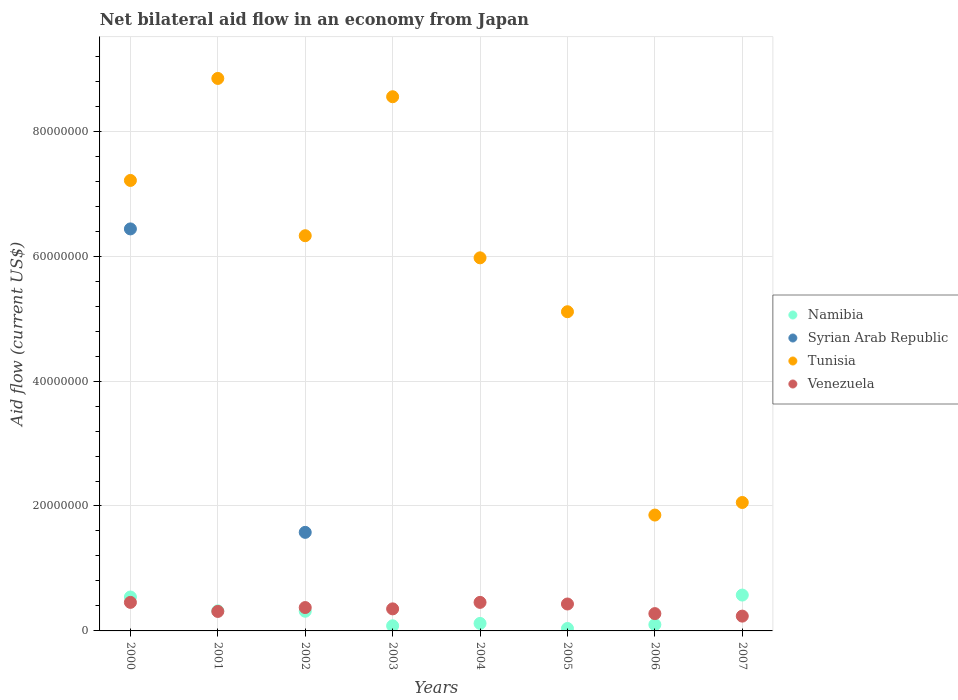What is the net bilateral aid flow in Tunisia in 2000?
Offer a terse response. 7.21e+07. Across all years, what is the maximum net bilateral aid flow in Namibia?
Ensure brevity in your answer.  5.74e+06. Across all years, what is the minimum net bilateral aid flow in Tunisia?
Provide a short and direct response. 1.86e+07. In which year was the net bilateral aid flow in Namibia maximum?
Provide a short and direct response. 2007. What is the total net bilateral aid flow in Syrian Arab Republic in the graph?
Ensure brevity in your answer.  8.01e+07. What is the difference between the net bilateral aid flow in Tunisia in 2005 and the net bilateral aid flow in Namibia in 2000?
Your answer should be very brief. 4.57e+07. What is the average net bilateral aid flow in Namibia per year?
Your answer should be very brief. 2.62e+06. In the year 2001, what is the difference between the net bilateral aid flow in Namibia and net bilateral aid flow in Tunisia?
Offer a very short reply. -8.52e+07. What is the ratio of the net bilateral aid flow in Tunisia in 2002 to that in 2003?
Your response must be concise. 0.74. What is the difference between the highest and the second highest net bilateral aid flow in Venezuela?
Keep it short and to the point. 0. What is the difference between the highest and the lowest net bilateral aid flow in Syrian Arab Republic?
Offer a very short reply. 6.44e+07. Is the sum of the net bilateral aid flow in Namibia in 2002 and 2004 greater than the maximum net bilateral aid flow in Syrian Arab Republic across all years?
Your answer should be very brief. No. Is it the case that in every year, the sum of the net bilateral aid flow in Namibia and net bilateral aid flow in Tunisia  is greater than the sum of net bilateral aid flow in Syrian Arab Republic and net bilateral aid flow in Venezuela?
Keep it short and to the point. No. Does the net bilateral aid flow in Tunisia monotonically increase over the years?
Provide a short and direct response. No. Is the net bilateral aid flow in Syrian Arab Republic strictly greater than the net bilateral aid flow in Tunisia over the years?
Your answer should be compact. No. How many years are there in the graph?
Offer a very short reply. 8. Where does the legend appear in the graph?
Give a very brief answer. Center right. What is the title of the graph?
Give a very brief answer. Net bilateral aid flow in an economy from Japan. What is the label or title of the X-axis?
Offer a terse response. Years. What is the label or title of the Y-axis?
Offer a very short reply. Aid flow (current US$). What is the Aid flow (current US$) of Namibia in 2000?
Your response must be concise. 5.43e+06. What is the Aid flow (current US$) in Syrian Arab Republic in 2000?
Your response must be concise. 6.44e+07. What is the Aid flow (current US$) in Tunisia in 2000?
Keep it short and to the point. 7.21e+07. What is the Aid flow (current US$) in Venezuela in 2000?
Give a very brief answer. 4.57e+06. What is the Aid flow (current US$) of Namibia in 2001?
Your answer should be very brief. 3.21e+06. What is the Aid flow (current US$) in Syrian Arab Republic in 2001?
Your answer should be compact. 0. What is the Aid flow (current US$) in Tunisia in 2001?
Your response must be concise. 8.84e+07. What is the Aid flow (current US$) in Venezuela in 2001?
Give a very brief answer. 3.12e+06. What is the Aid flow (current US$) in Namibia in 2002?
Offer a terse response. 3.15e+06. What is the Aid flow (current US$) of Syrian Arab Republic in 2002?
Provide a succinct answer. 1.58e+07. What is the Aid flow (current US$) in Tunisia in 2002?
Your response must be concise. 6.33e+07. What is the Aid flow (current US$) in Venezuela in 2002?
Keep it short and to the point. 3.74e+06. What is the Aid flow (current US$) of Namibia in 2003?
Keep it short and to the point. 8.20e+05. What is the Aid flow (current US$) of Tunisia in 2003?
Offer a terse response. 8.55e+07. What is the Aid flow (current US$) in Venezuela in 2003?
Your answer should be very brief. 3.53e+06. What is the Aid flow (current US$) in Namibia in 2004?
Your answer should be very brief. 1.20e+06. What is the Aid flow (current US$) in Syrian Arab Republic in 2004?
Your answer should be very brief. 0. What is the Aid flow (current US$) of Tunisia in 2004?
Provide a succinct answer. 5.97e+07. What is the Aid flow (current US$) in Venezuela in 2004?
Give a very brief answer. 4.57e+06. What is the Aid flow (current US$) in Syrian Arab Republic in 2005?
Keep it short and to the point. 0. What is the Aid flow (current US$) of Tunisia in 2005?
Your answer should be compact. 5.11e+07. What is the Aid flow (current US$) of Venezuela in 2005?
Make the answer very short. 4.31e+06. What is the Aid flow (current US$) in Namibia in 2006?
Offer a very short reply. 1.01e+06. What is the Aid flow (current US$) in Tunisia in 2006?
Keep it short and to the point. 1.86e+07. What is the Aid flow (current US$) of Venezuela in 2006?
Give a very brief answer. 2.77e+06. What is the Aid flow (current US$) of Namibia in 2007?
Provide a short and direct response. 5.74e+06. What is the Aid flow (current US$) of Syrian Arab Republic in 2007?
Your answer should be very brief. 0. What is the Aid flow (current US$) of Tunisia in 2007?
Your answer should be compact. 2.06e+07. What is the Aid flow (current US$) in Venezuela in 2007?
Make the answer very short. 2.37e+06. Across all years, what is the maximum Aid flow (current US$) of Namibia?
Provide a succinct answer. 5.74e+06. Across all years, what is the maximum Aid flow (current US$) of Syrian Arab Republic?
Give a very brief answer. 6.44e+07. Across all years, what is the maximum Aid flow (current US$) in Tunisia?
Your response must be concise. 8.84e+07. Across all years, what is the maximum Aid flow (current US$) of Venezuela?
Offer a terse response. 4.57e+06. Across all years, what is the minimum Aid flow (current US$) of Syrian Arab Republic?
Your response must be concise. 0. Across all years, what is the minimum Aid flow (current US$) in Tunisia?
Provide a succinct answer. 1.86e+07. Across all years, what is the minimum Aid flow (current US$) in Venezuela?
Your answer should be compact. 2.37e+06. What is the total Aid flow (current US$) of Namibia in the graph?
Provide a short and direct response. 2.10e+07. What is the total Aid flow (current US$) of Syrian Arab Republic in the graph?
Keep it short and to the point. 8.01e+07. What is the total Aid flow (current US$) of Tunisia in the graph?
Give a very brief answer. 4.59e+08. What is the total Aid flow (current US$) in Venezuela in the graph?
Offer a terse response. 2.90e+07. What is the difference between the Aid flow (current US$) of Namibia in 2000 and that in 2001?
Provide a succinct answer. 2.22e+06. What is the difference between the Aid flow (current US$) in Tunisia in 2000 and that in 2001?
Offer a terse response. -1.63e+07. What is the difference between the Aid flow (current US$) in Venezuela in 2000 and that in 2001?
Make the answer very short. 1.45e+06. What is the difference between the Aid flow (current US$) of Namibia in 2000 and that in 2002?
Provide a succinct answer. 2.28e+06. What is the difference between the Aid flow (current US$) in Syrian Arab Republic in 2000 and that in 2002?
Offer a terse response. 4.86e+07. What is the difference between the Aid flow (current US$) of Tunisia in 2000 and that in 2002?
Your response must be concise. 8.85e+06. What is the difference between the Aid flow (current US$) of Venezuela in 2000 and that in 2002?
Provide a succinct answer. 8.30e+05. What is the difference between the Aid flow (current US$) in Namibia in 2000 and that in 2003?
Offer a terse response. 4.61e+06. What is the difference between the Aid flow (current US$) in Tunisia in 2000 and that in 2003?
Offer a terse response. -1.34e+07. What is the difference between the Aid flow (current US$) in Venezuela in 2000 and that in 2003?
Keep it short and to the point. 1.04e+06. What is the difference between the Aid flow (current US$) of Namibia in 2000 and that in 2004?
Offer a very short reply. 4.23e+06. What is the difference between the Aid flow (current US$) of Tunisia in 2000 and that in 2004?
Your answer should be compact. 1.24e+07. What is the difference between the Aid flow (current US$) of Venezuela in 2000 and that in 2004?
Keep it short and to the point. 0. What is the difference between the Aid flow (current US$) in Namibia in 2000 and that in 2005?
Make the answer very short. 5.04e+06. What is the difference between the Aid flow (current US$) of Tunisia in 2000 and that in 2005?
Your response must be concise. 2.10e+07. What is the difference between the Aid flow (current US$) in Venezuela in 2000 and that in 2005?
Your response must be concise. 2.60e+05. What is the difference between the Aid flow (current US$) of Namibia in 2000 and that in 2006?
Your answer should be compact. 4.42e+06. What is the difference between the Aid flow (current US$) in Tunisia in 2000 and that in 2006?
Keep it short and to the point. 5.36e+07. What is the difference between the Aid flow (current US$) in Venezuela in 2000 and that in 2006?
Offer a very short reply. 1.80e+06. What is the difference between the Aid flow (current US$) of Namibia in 2000 and that in 2007?
Offer a very short reply. -3.10e+05. What is the difference between the Aid flow (current US$) in Tunisia in 2000 and that in 2007?
Your answer should be very brief. 5.16e+07. What is the difference between the Aid flow (current US$) in Venezuela in 2000 and that in 2007?
Offer a very short reply. 2.20e+06. What is the difference between the Aid flow (current US$) in Tunisia in 2001 and that in 2002?
Your response must be concise. 2.52e+07. What is the difference between the Aid flow (current US$) in Venezuela in 2001 and that in 2002?
Give a very brief answer. -6.20e+05. What is the difference between the Aid flow (current US$) in Namibia in 2001 and that in 2003?
Ensure brevity in your answer.  2.39e+06. What is the difference between the Aid flow (current US$) in Tunisia in 2001 and that in 2003?
Provide a succinct answer. 2.93e+06. What is the difference between the Aid flow (current US$) in Venezuela in 2001 and that in 2003?
Provide a succinct answer. -4.10e+05. What is the difference between the Aid flow (current US$) in Namibia in 2001 and that in 2004?
Your answer should be compact. 2.01e+06. What is the difference between the Aid flow (current US$) in Tunisia in 2001 and that in 2004?
Keep it short and to the point. 2.87e+07. What is the difference between the Aid flow (current US$) of Venezuela in 2001 and that in 2004?
Ensure brevity in your answer.  -1.45e+06. What is the difference between the Aid flow (current US$) of Namibia in 2001 and that in 2005?
Give a very brief answer. 2.82e+06. What is the difference between the Aid flow (current US$) of Tunisia in 2001 and that in 2005?
Give a very brief answer. 3.74e+07. What is the difference between the Aid flow (current US$) of Venezuela in 2001 and that in 2005?
Provide a short and direct response. -1.19e+06. What is the difference between the Aid flow (current US$) in Namibia in 2001 and that in 2006?
Give a very brief answer. 2.20e+06. What is the difference between the Aid flow (current US$) in Tunisia in 2001 and that in 2006?
Offer a very short reply. 6.99e+07. What is the difference between the Aid flow (current US$) of Venezuela in 2001 and that in 2006?
Your answer should be compact. 3.50e+05. What is the difference between the Aid flow (current US$) of Namibia in 2001 and that in 2007?
Offer a very short reply. -2.53e+06. What is the difference between the Aid flow (current US$) of Tunisia in 2001 and that in 2007?
Your response must be concise. 6.79e+07. What is the difference between the Aid flow (current US$) in Venezuela in 2001 and that in 2007?
Give a very brief answer. 7.50e+05. What is the difference between the Aid flow (current US$) in Namibia in 2002 and that in 2003?
Offer a very short reply. 2.33e+06. What is the difference between the Aid flow (current US$) of Tunisia in 2002 and that in 2003?
Give a very brief answer. -2.22e+07. What is the difference between the Aid flow (current US$) in Namibia in 2002 and that in 2004?
Make the answer very short. 1.95e+06. What is the difference between the Aid flow (current US$) in Tunisia in 2002 and that in 2004?
Ensure brevity in your answer.  3.54e+06. What is the difference between the Aid flow (current US$) of Venezuela in 2002 and that in 2004?
Offer a terse response. -8.30e+05. What is the difference between the Aid flow (current US$) in Namibia in 2002 and that in 2005?
Ensure brevity in your answer.  2.76e+06. What is the difference between the Aid flow (current US$) in Tunisia in 2002 and that in 2005?
Your answer should be compact. 1.22e+07. What is the difference between the Aid flow (current US$) in Venezuela in 2002 and that in 2005?
Give a very brief answer. -5.70e+05. What is the difference between the Aid flow (current US$) of Namibia in 2002 and that in 2006?
Your answer should be very brief. 2.14e+06. What is the difference between the Aid flow (current US$) in Tunisia in 2002 and that in 2006?
Ensure brevity in your answer.  4.47e+07. What is the difference between the Aid flow (current US$) in Venezuela in 2002 and that in 2006?
Keep it short and to the point. 9.70e+05. What is the difference between the Aid flow (current US$) in Namibia in 2002 and that in 2007?
Give a very brief answer. -2.59e+06. What is the difference between the Aid flow (current US$) of Tunisia in 2002 and that in 2007?
Your answer should be very brief. 4.27e+07. What is the difference between the Aid flow (current US$) of Venezuela in 2002 and that in 2007?
Provide a succinct answer. 1.37e+06. What is the difference between the Aid flow (current US$) of Namibia in 2003 and that in 2004?
Offer a very short reply. -3.80e+05. What is the difference between the Aid flow (current US$) of Tunisia in 2003 and that in 2004?
Provide a succinct answer. 2.58e+07. What is the difference between the Aid flow (current US$) of Venezuela in 2003 and that in 2004?
Offer a terse response. -1.04e+06. What is the difference between the Aid flow (current US$) of Namibia in 2003 and that in 2005?
Your answer should be very brief. 4.30e+05. What is the difference between the Aid flow (current US$) in Tunisia in 2003 and that in 2005?
Keep it short and to the point. 3.44e+07. What is the difference between the Aid flow (current US$) in Venezuela in 2003 and that in 2005?
Give a very brief answer. -7.80e+05. What is the difference between the Aid flow (current US$) of Tunisia in 2003 and that in 2006?
Your answer should be very brief. 6.70e+07. What is the difference between the Aid flow (current US$) of Venezuela in 2003 and that in 2006?
Offer a terse response. 7.60e+05. What is the difference between the Aid flow (current US$) in Namibia in 2003 and that in 2007?
Provide a succinct answer. -4.92e+06. What is the difference between the Aid flow (current US$) of Tunisia in 2003 and that in 2007?
Provide a short and direct response. 6.50e+07. What is the difference between the Aid flow (current US$) of Venezuela in 2003 and that in 2007?
Keep it short and to the point. 1.16e+06. What is the difference between the Aid flow (current US$) of Namibia in 2004 and that in 2005?
Offer a very short reply. 8.10e+05. What is the difference between the Aid flow (current US$) of Tunisia in 2004 and that in 2005?
Your response must be concise. 8.63e+06. What is the difference between the Aid flow (current US$) in Namibia in 2004 and that in 2006?
Give a very brief answer. 1.90e+05. What is the difference between the Aid flow (current US$) of Tunisia in 2004 and that in 2006?
Your answer should be compact. 4.12e+07. What is the difference between the Aid flow (current US$) in Venezuela in 2004 and that in 2006?
Give a very brief answer. 1.80e+06. What is the difference between the Aid flow (current US$) of Namibia in 2004 and that in 2007?
Offer a terse response. -4.54e+06. What is the difference between the Aid flow (current US$) of Tunisia in 2004 and that in 2007?
Offer a very short reply. 3.92e+07. What is the difference between the Aid flow (current US$) of Venezuela in 2004 and that in 2007?
Give a very brief answer. 2.20e+06. What is the difference between the Aid flow (current US$) in Namibia in 2005 and that in 2006?
Offer a very short reply. -6.20e+05. What is the difference between the Aid flow (current US$) of Tunisia in 2005 and that in 2006?
Offer a terse response. 3.26e+07. What is the difference between the Aid flow (current US$) in Venezuela in 2005 and that in 2006?
Offer a very short reply. 1.54e+06. What is the difference between the Aid flow (current US$) in Namibia in 2005 and that in 2007?
Offer a terse response. -5.35e+06. What is the difference between the Aid flow (current US$) in Tunisia in 2005 and that in 2007?
Make the answer very short. 3.05e+07. What is the difference between the Aid flow (current US$) in Venezuela in 2005 and that in 2007?
Your answer should be very brief. 1.94e+06. What is the difference between the Aid flow (current US$) in Namibia in 2006 and that in 2007?
Provide a succinct answer. -4.73e+06. What is the difference between the Aid flow (current US$) of Tunisia in 2006 and that in 2007?
Offer a very short reply. -2.01e+06. What is the difference between the Aid flow (current US$) of Namibia in 2000 and the Aid flow (current US$) of Tunisia in 2001?
Provide a succinct answer. -8.30e+07. What is the difference between the Aid flow (current US$) in Namibia in 2000 and the Aid flow (current US$) in Venezuela in 2001?
Your response must be concise. 2.31e+06. What is the difference between the Aid flow (current US$) of Syrian Arab Republic in 2000 and the Aid flow (current US$) of Tunisia in 2001?
Offer a very short reply. -2.41e+07. What is the difference between the Aid flow (current US$) of Syrian Arab Republic in 2000 and the Aid flow (current US$) of Venezuela in 2001?
Provide a short and direct response. 6.12e+07. What is the difference between the Aid flow (current US$) of Tunisia in 2000 and the Aid flow (current US$) of Venezuela in 2001?
Provide a short and direct response. 6.90e+07. What is the difference between the Aid flow (current US$) of Namibia in 2000 and the Aid flow (current US$) of Syrian Arab Republic in 2002?
Your answer should be compact. -1.04e+07. What is the difference between the Aid flow (current US$) of Namibia in 2000 and the Aid flow (current US$) of Tunisia in 2002?
Your answer should be compact. -5.78e+07. What is the difference between the Aid flow (current US$) in Namibia in 2000 and the Aid flow (current US$) in Venezuela in 2002?
Keep it short and to the point. 1.69e+06. What is the difference between the Aid flow (current US$) of Syrian Arab Republic in 2000 and the Aid flow (current US$) of Tunisia in 2002?
Ensure brevity in your answer.  1.09e+06. What is the difference between the Aid flow (current US$) of Syrian Arab Republic in 2000 and the Aid flow (current US$) of Venezuela in 2002?
Your answer should be compact. 6.06e+07. What is the difference between the Aid flow (current US$) of Tunisia in 2000 and the Aid flow (current US$) of Venezuela in 2002?
Your answer should be very brief. 6.84e+07. What is the difference between the Aid flow (current US$) in Namibia in 2000 and the Aid flow (current US$) in Tunisia in 2003?
Offer a terse response. -8.01e+07. What is the difference between the Aid flow (current US$) of Namibia in 2000 and the Aid flow (current US$) of Venezuela in 2003?
Provide a succinct answer. 1.90e+06. What is the difference between the Aid flow (current US$) of Syrian Arab Republic in 2000 and the Aid flow (current US$) of Tunisia in 2003?
Offer a very short reply. -2.12e+07. What is the difference between the Aid flow (current US$) of Syrian Arab Republic in 2000 and the Aid flow (current US$) of Venezuela in 2003?
Make the answer very short. 6.08e+07. What is the difference between the Aid flow (current US$) in Tunisia in 2000 and the Aid flow (current US$) in Venezuela in 2003?
Your answer should be very brief. 6.86e+07. What is the difference between the Aid flow (current US$) of Namibia in 2000 and the Aid flow (current US$) of Tunisia in 2004?
Offer a terse response. -5.43e+07. What is the difference between the Aid flow (current US$) of Namibia in 2000 and the Aid flow (current US$) of Venezuela in 2004?
Your answer should be very brief. 8.60e+05. What is the difference between the Aid flow (current US$) in Syrian Arab Republic in 2000 and the Aid flow (current US$) in Tunisia in 2004?
Keep it short and to the point. 4.63e+06. What is the difference between the Aid flow (current US$) in Syrian Arab Republic in 2000 and the Aid flow (current US$) in Venezuela in 2004?
Your answer should be very brief. 5.98e+07. What is the difference between the Aid flow (current US$) of Tunisia in 2000 and the Aid flow (current US$) of Venezuela in 2004?
Your response must be concise. 6.76e+07. What is the difference between the Aid flow (current US$) of Namibia in 2000 and the Aid flow (current US$) of Tunisia in 2005?
Ensure brevity in your answer.  -4.57e+07. What is the difference between the Aid flow (current US$) in Namibia in 2000 and the Aid flow (current US$) in Venezuela in 2005?
Give a very brief answer. 1.12e+06. What is the difference between the Aid flow (current US$) of Syrian Arab Republic in 2000 and the Aid flow (current US$) of Tunisia in 2005?
Your answer should be compact. 1.33e+07. What is the difference between the Aid flow (current US$) of Syrian Arab Republic in 2000 and the Aid flow (current US$) of Venezuela in 2005?
Your answer should be very brief. 6.00e+07. What is the difference between the Aid flow (current US$) of Tunisia in 2000 and the Aid flow (current US$) of Venezuela in 2005?
Your answer should be very brief. 6.78e+07. What is the difference between the Aid flow (current US$) of Namibia in 2000 and the Aid flow (current US$) of Tunisia in 2006?
Provide a short and direct response. -1.31e+07. What is the difference between the Aid flow (current US$) of Namibia in 2000 and the Aid flow (current US$) of Venezuela in 2006?
Provide a short and direct response. 2.66e+06. What is the difference between the Aid flow (current US$) in Syrian Arab Republic in 2000 and the Aid flow (current US$) in Tunisia in 2006?
Your answer should be compact. 4.58e+07. What is the difference between the Aid flow (current US$) in Syrian Arab Republic in 2000 and the Aid flow (current US$) in Venezuela in 2006?
Offer a terse response. 6.16e+07. What is the difference between the Aid flow (current US$) in Tunisia in 2000 and the Aid flow (current US$) in Venezuela in 2006?
Provide a succinct answer. 6.94e+07. What is the difference between the Aid flow (current US$) in Namibia in 2000 and the Aid flow (current US$) in Tunisia in 2007?
Provide a succinct answer. -1.51e+07. What is the difference between the Aid flow (current US$) of Namibia in 2000 and the Aid flow (current US$) of Venezuela in 2007?
Offer a terse response. 3.06e+06. What is the difference between the Aid flow (current US$) of Syrian Arab Republic in 2000 and the Aid flow (current US$) of Tunisia in 2007?
Your answer should be very brief. 4.38e+07. What is the difference between the Aid flow (current US$) of Syrian Arab Republic in 2000 and the Aid flow (current US$) of Venezuela in 2007?
Offer a terse response. 6.20e+07. What is the difference between the Aid flow (current US$) of Tunisia in 2000 and the Aid flow (current US$) of Venezuela in 2007?
Keep it short and to the point. 6.98e+07. What is the difference between the Aid flow (current US$) of Namibia in 2001 and the Aid flow (current US$) of Syrian Arab Republic in 2002?
Your answer should be very brief. -1.26e+07. What is the difference between the Aid flow (current US$) of Namibia in 2001 and the Aid flow (current US$) of Tunisia in 2002?
Your answer should be compact. -6.01e+07. What is the difference between the Aid flow (current US$) of Namibia in 2001 and the Aid flow (current US$) of Venezuela in 2002?
Your response must be concise. -5.30e+05. What is the difference between the Aid flow (current US$) in Tunisia in 2001 and the Aid flow (current US$) in Venezuela in 2002?
Your response must be concise. 8.47e+07. What is the difference between the Aid flow (current US$) in Namibia in 2001 and the Aid flow (current US$) in Tunisia in 2003?
Provide a short and direct response. -8.23e+07. What is the difference between the Aid flow (current US$) of Namibia in 2001 and the Aid flow (current US$) of Venezuela in 2003?
Provide a short and direct response. -3.20e+05. What is the difference between the Aid flow (current US$) in Tunisia in 2001 and the Aid flow (current US$) in Venezuela in 2003?
Your answer should be very brief. 8.49e+07. What is the difference between the Aid flow (current US$) of Namibia in 2001 and the Aid flow (current US$) of Tunisia in 2004?
Give a very brief answer. -5.65e+07. What is the difference between the Aid flow (current US$) in Namibia in 2001 and the Aid flow (current US$) in Venezuela in 2004?
Keep it short and to the point. -1.36e+06. What is the difference between the Aid flow (current US$) of Tunisia in 2001 and the Aid flow (current US$) of Venezuela in 2004?
Your response must be concise. 8.39e+07. What is the difference between the Aid flow (current US$) of Namibia in 2001 and the Aid flow (current US$) of Tunisia in 2005?
Give a very brief answer. -4.79e+07. What is the difference between the Aid flow (current US$) in Namibia in 2001 and the Aid flow (current US$) in Venezuela in 2005?
Your answer should be compact. -1.10e+06. What is the difference between the Aid flow (current US$) in Tunisia in 2001 and the Aid flow (current US$) in Venezuela in 2005?
Offer a terse response. 8.41e+07. What is the difference between the Aid flow (current US$) in Namibia in 2001 and the Aid flow (current US$) in Tunisia in 2006?
Offer a terse response. -1.53e+07. What is the difference between the Aid flow (current US$) of Tunisia in 2001 and the Aid flow (current US$) of Venezuela in 2006?
Give a very brief answer. 8.57e+07. What is the difference between the Aid flow (current US$) in Namibia in 2001 and the Aid flow (current US$) in Tunisia in 2007?
Make the answer very short. -1.74e+07. What is the difference between the Aid flow (current US$) of Namibia in 2001 and the Aid flow (current US$) of Venezuela in 2007?
Give a very brief answer. 8.40e+05. What is the difference between the Aid flow (current US$) of Tunisia in 2001 and the Aid flow (current US$) of Venezuela in 2007?
Make the answer very short. 8.61e+07. What is the difference between the Aid flow (current US$) in Namibia in 2002 and the Aid flow (current US$) in Tunisia in 2003?
Offer a very short reply. -8.24e+07. What is the difference between the Aid flow (current US$) in Namibia in 2002 and the Aid flow (current US$) in Venezuela in 2003?
Provide a succinct answer. -3.80e+05. What is the difference between the Aid flow (current US$) of Syrian Arab Republic in 2002 and the Aid flow (current US$) of Tunisia in 2003?
Provide a short and direct response. -6.97e+07. What is the difference between the Aid flow (current US$) in Syrian Arab Republic in 2002 and the Aid flow (current US$) in Venezuela in 2003?
Make the answer very short. 1.22e+07. What is the difference between the Aid flow (current US$) of Tunisia in 2002 and the Aid flow (current US$) of Venezuela in 2003?
Provide a short and direct response. 5.97e+07. What is the difference between the Aid flow (current US$) of Namibia in 2002 and the Aid flow (current US$) of Tunisia in 2004?
Offer a very short reply. -5.66e+07. What is the difference between the Aid flow (current US$) in Namibia in 2002 and the Aid flow (current US$) in Venezuela in 2004?
Provide a succinct answer. -1.42e+06. What is the difference between the Aid flow (current US$) in Syrian Arab Republic in 2002 and the Aid flow (current US$) in Tunisia in 2004?
Your response must be concise. -4.40e+07. What is the difference between the Aid flow (current US$) in Syrian Arab Republic in 2002 and the Aid flow (current US$) in Venezuela in 2004?
Your answer should be compact. 1.12e+07. What is the difference between the Aid flow (current US$) of Tunisia in 2002 and the Aid flow (current US$) of Venezuela in 2004?
Keep it short and to the point. 5.87e+07. What is the difference between the Aid flow (current US$) of Namibia in 2002 and the Aid flow (current US$) of Tunisia in 2005?
Your response must be concise. -4.80e+07. What is the difference between the Aid flow (current US$) of Namibia in 2002 and the Aid flow (current US$) of Venezuela in 2005?
Provide a succinct answer. -1.16e+06. What is the difference between the Aid flow (current US$) of Syrian Arab Republic in 2002 and the Aid flow (current US$) of Tunisia in 2005?
Provide a succinct answer. -3.53e+07. What is the difference between the Aid flow (current US$) of Syrian Arab Republic in 2002 and the Aid flow (current US$) of Venezuela in 2005?
Give a very brief answer. 1.15e+07. What is the difference between the Aid flow (current US$) in Tunisia in 2002 and the Aid flow (current US$) in Venezuela in 2005?
Offer a terse response. 5.90e+07. What is the difference between the Aid flow (current US$) of Namibia in 2002 and the Aid flow (current US$) of Tunisia in 2006?
Your answer should be compact. -1.54e+07. What is the difference between the Aid flow (current US$) in Syrian Arab Republic in 2002 and the Aid flow (current US$) in Tunisia in 2006?
Offer a very short reply. -2.77e+06. What is the difference between the Aid flow (current US$) of Syrian Arab Republic in 2002 and the Aid flow (current US$) of Venezuela in 2006?
Your answer should be very brief. 1.30e+07. What is the difference between the Aid flow (current US$) of Tunisia in 2002 and the Aid flow (current US$) of Venezuela in 2006?
Make the answer very short. 6.05e+07. What is the difference between the Aid flow (current US$) in Namibia in 2002 and the Aid flow (current US$) in Tunisia in 2007?
Your answer should be very brief. -1.74e+07. What is the difference between the Aid flow (current US$) in Namibia in 2002 and the Aid flow (current US$) in Venezuela in 2007?
Give a very brief answer. 7.80e+05. What is the difference between the Aid flow (current US$) of Syrian Arab Republic in 2002 and the Aid flow (current US$) of Tunisia in 2007?
Make the answer very short. -4.78e+06. What is the difference between the Aid flow (current US$) in Syrian Arab Republic in 2002 and the Aid flow (current US$) in Venezuela in 2007?
Provide a short and direct response. 1.34e+07. What is the difference between the Aid flow (current US$) in Tunisia in 2002 and the Aid flow (current US$) in Venezuela in 2007?
Make the answer very short. 6.09e+07. What is the difference between the Aid flow (current US$) of Namibia in 2003 and the Aid flow (current US$) of Tunisia in 2004?
Give a very brief answer. -5.89e+07. What is the difference between the Aid flow (current US$) in Namibia in 2003 and the Aid flow (current US$) in Venezuela in 2004?
Ensure brevity in your answer.  -3.75e+06. What is the difference between the Aid flow (current US$) in Tunisia in 2003 and the Aid flow (current US$) in Venezuela in 2004?
Your answer should be compact. 8.10e+07. What is the difference between the Aid flow (current US$) in Namibia in 2003 and the Aid flow (current US$) in Tunisia in 2005?
Ensure brevity in your answer.  -5.03e+07. What is the difference between the Aid flow (current US$) in Namibia in 2003 and the Aid flow (current US$) in Venezuela in 2005?
Give a very brief answer. -3.49e+06. What is the difference between the Aid flow (current US$) in Tunisia in 2003 and the Aid flow (current US$) in Venezuela in 2005?
Provide a short and direct response. 8.12e+07. What is the difference between the Aid flow (current US$) in Namibia in 2003 and the Aid flow (current US$) in Tunisia in 2006?
Offer a terse response. -1.77e+07. What is the difference between the Aid flow (current US$) in Namibia in 2003 and the Aid flow (current US$) in Venezuela in 2006?
Offer a very short reply. -1.95e+06. What is the difference between the Aid flow (current US$) of Tunisia in 2003 and the Aid flow (current US$) of Venezuela in 2006?
Your answer should be compact. 8.28e+07. What is the difference between the Aid flow (current US$) of Namibia in 2003 and the Aid flow (current US$) of Tunisia in 2007?
Provide a short and direct response. -1.97e+07. What is the difference between the Aid flow (current US$) of Namibia in 2003 and the Aid flow (current US$) of Venezuela in 2007?
Keep it short and to the point. -1.55e+06. What is the difference between the Aid flow (current US$) in Tunisia in 2003 and the Aid flow (current US$) in Venezuela in 2007?
Offer a terse response. 8.32e+07. What is the difference between the Aid flow (current US$) of Namibia in 2004 and the Aid flow (current US$) of Tunisia in 2005?
Your answer should be very brief. -4.99e+07. What is the difference between the Aid flow (current US$) of Namibia in 2004 and the Aid flow (current US$) of Venezuela in 2005?
Provide a short and direct response. -3.11e+06. What is the difference between the Aid flow (current US$) of Tunisia in 2004 and the Aid flow (current US$) of Venezuela in 2005?
Keep it short and to the point. 5.54e+07. What is the difference between the Aid flow (current US$) in Namibia in 2004 and the Aid flow (current US$) in Tunisia in 2006?
Give a very brief answer. -1.74e+07. What is the difference between the Aid flow (current US$) of Namibia in 2004 and the Aid flow (current US$) of Venezuela in 2006?
Keep it short and to the point. -1.57e+06. What is the difference between the Aid flow (current US$) in Tunisia in 2004 and the Aid flow (current US$) in Venezuela in 2006?
Offer a very short reply. 5.70e+07. What is the difference between the Aid flow (current US$) of Namibia in 2004 and the Aid flow (current US$) of Tunisia in 2007?
Provide a succinct answer. -1.94e+07. What is the difference between the Aid flow (current US$) in Namibia in 2004 and the Aid flow (current US$) in Venezuela in 2007?
Provide a succinct answer. -1.17e+06. What is the difference between the Aid flow (current US$) of Tunisia in 2004 and the Aid flow (current US$) of Venezuela in 2007?
Provide a succinct answer. 5.74e+07. What is the difference between the Aid flow (current US$) in Namibia in 2005 and the Aid flow (current US$) in Tunisia in 2006?
Ensure brevity in your answer.  -1.82e+07. What is the difference between the Aid flow (current US$) in Namibia in 2005 and the Aid flow (current US$) in Venezuela in 2006?
Your answer should be very brief. -2.38e+06. What is the difference between the Aid flow (current US$) in Tunisia in 2005 and the Aid flow (current US$) in Venezuela in 2006?
Your answer should be very brief. 4.83e+07. What is the difference between the Aid flow (current US$) in Namibia in 2005 and the Aid flow (current US$) in Tunisia in 2007?
Keep it short and to the point. -2.02e+07. What is the difference between the Aid flow (current US$) of Namibia in 2005 and the Aid flow (current US$) of Venezuela in 2007?
Offer a terse response. -1.98e+06. What is the difference between the Aid flow (current US$) of Tunisia in 2005 and the Aid flow (current US$) of Venezuela in 2007?
Make the answer very short. 4.87e+07. What is the difference between the Aid flow (current US$) of Namibia in 2006 and the Aid flow (current US$) of Tunisia in 2007?
Your response must be concise. -1.96e+07. What is the difference between the Aid flow (current US$) in Namibia in 2006 and the Aid flow (current US$) in Venezuela in 2007?
Offer a very short reply. -1.36e+06. What is the difference between the Aid flow (current US$) in Tunisia in 2006 and the Aid flow (current US$) in Venezuela in 2007?
Your answer should be compact. 1.62e+07. What is the average Aid flow (current US$) in Namibia per year?
Keep it short and to the point. 2.62e+06. What is the average Aid flow (current US$) in Syrian Arab Republic per year?
Ensure brevity in your answer.  1.00e+07. What is the average Aid flow (current US$) in Tunisia per year?
Offer a terse response. 5.74e+07. What is the average Aid flow (current US$) in Venezuela per year?
Provide a short and direct response. 3.62e+06. In the year 2000, what is the difference between the Aid flow (current US$) in Namibia and Aid flow (current US$) in Syrian Arab Republic?
Ensure brevity in your answer.  -5.89e+07. In the year 2000, what is the difference between the Aid flow (current US$) of Namibia and Aid flow (current US$) of Tunisia?
Offer a terse response. -6.67e+07. In the year 2000, what is the difference between the Aid flow (current US$) of Namibia and Aid flow (current US$) of Venezuela?
Offer a terse response. 8.60e+05. In the year 2000, what is the difference between the Aid flow (current US$) in Syrian Arab Republic and Aid flow (current US$) in Tunisia?
Offer a very short reply. -7.76e+06. In the year 2000, what is the difference between the Aid flow (current US$) in Syrian Arab Republic and Aid flow (current US$) in Venezuela?
Ensure brevity in your answer.  5.98e+07. In the year 2000, what is the difference between the Aid flow (current US$) in Tunisia and Aid flow (current US$) in Venezuela?
Provide a short and direct response. 6.76e+07. In the year 2001, what is the difference between the Aid flow (current US$) of Namibia and Aid flow (current US$) of Tunisia?
Your response must be concise. -8.52e+07. In the year 2001, what is the difference between the Aid flow (current US$) of Tunisia and Aid flow (current US$) of Venezuela?
Provide a short and direct response. 8.53e+07. In the year 2002, what is the difference between the Aid flow (current US$) of Namibia and Aid flow (current US$) of Syrian Arab Republic?
Offer a very short reply. -1.26e+07. In the year 2002, what is the difference between the Aid flow (current US$) of Namibia and Aid flow (current US$) of Tunisia?
Your response must be concise. -6.01e+07. In the year 2002, what is the difference between the Aid flow (current US$) of Namibia and Aid flow (current US$) of Venezuela?
Your answer should be compact. -5.90e+05. In the year 2002, what is the difference between the Aid flow (current US$) of Syrian Arab Republic and Aid flow (current US$) of Tunisia?
Ensure brevity in your answer.  -4.75e+07. In the year 2002, what is the difference between the Aid flow (current US$) in Syrian Arab Republic and Aid flow (current US$) in Venezuela?
Your answer should be compact. 1.20e+07. In the year 2002, what is the difference between the Aid flow (current US$) of Tunisia and Aid flow (current US$) of Venezuela?
Provide a short and direct response. 5.95e+07. In the year 2003, what is the difference between the Aid flow (current US$) in Namibia and Aid flow (current US$) in Tunisia?
Ensure brevity in your answer.  -8.47e+07. In the year 2003, what is the difference between the Aid flow (current US$) of Namibia and Aid flow (current US$) of Venezuela?
Your answer should be compact. -2.71e+06. In the year 2003, what is the difference between the Aid flow (current US$) of Tunisia and Aid flow (current US$) of Venezuela?
Provide a short and direct response. 8.20e+07. In the year 2004, what is the difference between the Aid flow (current US$) in Namibia and Aid flow (current US$) in Tunisia?
Your answer should be very brief. -5.85e+07. In the year 2004, what is the difference between the Aid flow (current US$) of Namibia and Aid flow (current US$) of Venezuela?
Provide a short and direct response. -3.37e+06. In the year 2004, what is the difference between the Aid flow (current US$) in Tunisia and Aid flow (current US$) in Venezuela?
Keep it short and to the point. 5.52e+07. In the year 2005, what is the difference between the Aid flow (current US$) in Namibia and Aid flow (current US$) in Tunisia?
Give a very brief answer. -5.07e+07. In the year 2005, what is the difference between the Aid flow (current US$) of Namibia and Aid flow (current US$) of Venezuela?
Offer a very short reply. -3.92e+06. In the year 2005, what is the difference between the Aid flow (current US$) in Tunisia and Aid flow (current US$) in Venezuela?
Your answer should be compact. 4.68e+07. In the year 2006, what is the difference between the Aid flow (current US$) in Namibia and Aid flow (current US$) in Tunisia?
Offer a terse response. -1.75e+07. In the year 2006, what is the difference between the Aid flow (current US$) in Namibia and Aid flow (current US$) in Venezuela?
Keep it short and to the point. -1.76e+06. In the year 2006, what is the difference between the Aid flow (current US$) in Tunisia and Aid flow (current US$) in Venezuela?
Provide a succinct answer. 1.58e+07. In the year 2007, what is the difference between the Aid flow (current US$) in Namibia and Aid flow (current US$) in Tunisia?
Keep it short and to the point. -1.48e+07. In the year 2007, what is the difference between the Aid flow (current US$) in Namibia and Aid flow (current US$) in Venezuela?
Offer a very short reply. 3.37e+06. In the year 2007, what is the difference between the Aid flow (current US$) of Tunisia and Aid flow (current US$) of Venezuela?
Offer a very short reply. 1.82e+07. What is the ratio of the Aid flow (current US$) in Namibia in 2000 to that in 2001?
Give a very brief answer. 1.69. What is the ratio of the Aid flow (current US$) of Tunisia in 2000 to that in 2001?
Make the answer very short. 0.82. What is the ratio of the Aid flow (current US$) in Venezuela in 2000 to that in 2001?
Offer a very short reply. 1.46. What is the ratio of the Aid flow (current US$) of Namibia in 2000 to that in 2002?
Keep it short and to the point. 1.72. What is the ratio of the Aid flow (current US$) of Syrian Arab Republic in 2000 to that in 2002?
Your answer should be very brief. 4.08. What is the ratio of the Aid flow (current US$) in Tunisia in 2000 to that in 2002?
Offer a terse response. 1.14. What is the ratio of the Aid flow (current US$) of Venezuela in 2000 to that in 2002?
Keep it short and to the point. 1.22. What is the ratio of the Aid flow (current US$) of Namibia in 2000 to that in 2003?
Ensure brevity in your answer.  6.62. What is the ratio of the Aid flow (current US$) in Tunisia in 2000 to that in 2003?
Provide a short and direct response. 0.84. What is the ratio of the Aid flow (current US$) of Venezuela in 2000 to that in 2003?
Your answer should be compact. 1.29. What is the ratio of the Aid flow (current US$) in Namibia in 2000 to that in 2004?
Offer a terse response. 4.53. What is the ratio of the Aid flow (current US$) in Tunisia in 2000 to that in 2004?
Provide a short and direct response. 1.21. What is the ratio of the Aid flow (current US$) of Venezuela in 2000 to that in 2004?
Your response must be concise. 1. What is the ratio of the Aid flow (current US$) in Namibia in 2000 to that in 2005?
Provide a succinct answer. 13.92. What is the ratio of the Aid flow (current US$) in Tunisia in 2000 to that in 2005?
Offer a terse response. 1.41. What is the ratio of the Aid flow (current US$) of Venezuela in 2000 to that in 2005?
Provide a short and direct response. 1.06. What is the ratio of the Aid flow (current US$) of Namibia in 2000 to that in 2006?
Make the answer very short. 5.38. What is the ratio of the Aid flow (current US$) in Tunisia in 2000 to that in 2006?
Your answer should be compact. 3.89. What is the ratio of the Aid flow (current US$) in Venezuela in 2000 to that in 2006?
Provide a short and direct response. 1.65. What is the ratio of the Aid flow (current US$) of Namibia in 2000 to that in 2007?
Offer a terse response. 0.95. What is the ratio of the Aid flow (current US$) in Tunisia in 2000 to that in 2007?
Keep it short and to the point. 3.51. What is the ratio of the Aid flow (current US$) of Venezuela in 2000 to that in 2007?
Make the answer very short. 1.93. What is the ratio of the Aid flow (current US$) in Tunisia in 2001 to that in 2002?
Your answer should be compact. 1.4. What is the ratio of the Aid flow (current US$) of Venezuela in 2001 to that in 2002?
Keep it short and to the point. 0.83. What is the ratio of the Aid flow (current US$) in Namibia in 2001 to that in 2003?
Your answer should be very brief. 3.91. What is the ratio of the Aid flow (current US$) in Tunisia in 2001 to that in 2003?
Give a very brief answer. 1.03. What is the ratio of the Aid flow (current US$) in Venezuela in 2001 to that in 2003?
Offer a terse response. 0.88. What is the ratio of the Aid flow (current US$) in Namibia in 2001 to that in 2004?
Make the answer very short. 2.67. What is the ratio of the Aid flow (current US$) of Tunisia in 2001 to that in 2004?
Make the answer very short. 1.48. What is the ratio of the Aid flow (current US$) of Venezuela in 2001 to that in 2004?
Give a very brief answer. 0.68. What is the ratio of the Aid flow (current US$) of Namibia in 2001 to that in 2005?
Provide a short and direct response. 8.23. What is the ratio of the Aid flow (current US$) of Tunisia in 2001 to that in 2005?
Your answer should be compact. 1.73. What is the ratio of the Aid flow (current US$) in Venezuela in 2001 to that in 2005?
Provide a succinct answer. 0.72. What is the ratio of the Aid flow (current US$) of Namibia in 2001 to that in 2006?
Keep it short and to the point. 3.18. What is the ratio of the Aid flow (current US$) in Tunisia in 2001 to that in 2006?
Your response must be concise. 4.77. What is the ratio of the Aid flow (current US$) in Venezuela in 2001 to that in 2006?
Provide a succinct answer. 1.13. What is the ratio of the Aid flow (current US$) of Namibia in 2001 to that in 2007?
Provide a succinct answer. 0.56. What is the ratio of the Aid flow (current US$) of Tunisia in 2001 to that in 2007?
Ensure brevity in your answer.  4.3. What is the ratio of the Aid flow (current US$) of Venezuela in 2001 to that in 2007?
Make the answer very short. 1.32. What is the ratio of the Aid flow (current US$) of Namibia in 2002 to that in 2003?
Offer a very short reply. 3.84. What is the ratio of the Aid flow (current US$) of Tunisia in 2002 to that in 2003?
Offer a terse response. 0.74. What is the ratio of the Aid flow (current US$) in Venezuela in 2002 to that in 2003?
Keep it short and to the point. 1.06. What is the ratio of the Aid flow (current US$) in Namibia in 2002 to that in 2004?
Give a very brief answer. 2.62. What is the ratio of the Aid flow (current US$) of Tunisia in 2002 to that in 2004?
Your answer should be very brief. 1.06. What is the ratio of the Aid flow (current US$) of Venezuela in 2002 to that in 2004?
Keep it short and to the point. 0.82. What is the ratio of the Aid flow (current US$) of Namibia in 2002 to that in 2005?
Offer a terse response. 8.08. What is the ratio of the Aid flow (current US$) in Tunisia in 2002 to that in 2005?
Make the answer very short. 1.24. What is the ratio of the Aid flow (current US$) in Venezuela in 2002 to that in 2005?
Give a very brief answer. 0.87. What is the ratio of the Aid flow (current US$) of Namibia in 2002 to that in 2006?
Make the answer very short. 3.12. What is the ratio of the Aid flow (current US$) of Tunisia in 2002 to that in 2006?
Provide a succinct answer. 3.41. What is the ratio of the Aid flow (current US$) of Venezuela in 2002 to that in 2006?
Keep it short and to the point. 1.35. What is the ratio of the Aid flow (current US$) of Namibia in 2002 to that in 2007?
Give a very brief answer. 0.55. What is the ratio of the Aid flow (current US$) of Tunisia in 2002 to that in 2007?
Offer a very short reply. 3.08. What is the ratio of the Aid flow (current US$) in Venezuela in 2002 to that in 2007?
Provide a short and direct response. 1.58. What is the ratio of the Aid flow (current US$) in Namibia in 2003 to that in 2004?
Make the answer very short. 0.68. What is the ratio of the Aid flow (current US$) in Tunisia in 2003 to that in 2004?
Your response must be concise. 1.43. What is the ratio of the Aid flow (current US$) in Venezuela in 2003 to that in 2004?
Keep it short and to the point. 0.77. What is the ratio of the Aid flow (current US$) of Namibia in 2003 to that in 2005?
Ensure brevity in your answer.  2.1. What is the ratio of the Aid flow (current US$) of Tunisia in 2003 to that in 2005?
Ensure brevity in your answer.  1.67. What is the ratio of the Aid flow (current US$) of Venezuela in 2003 to that in 2005?
Your answer should be compact. 0.82. What is the ratio of the Aid flow (current US$) in Namibia in 2003 to that in 2006?
Give a very brief answer. 0.81. What is the ratio of the Aid flow (current US$) in Tunisia in 2003 to that in 2006?
Your answer should be compact. 4.61. What is the ratio of the Aid flow (current US$) of Venezuela in 2003 to that in 2006?
Provide a short and direct response. 1.27. What is the ratio of the Aid flow (current US$) in Namibia in 2003 to that in 2007?
Your answer should be very brief. 0.14. What is the ratio of the Aid flow (current US$) in Tunisia in 2003 to that in 2007?
Ensure brevity in your answer.  4.16. What is the ratio of the Aid flow (current US$) of Venezuela in 2003 to that in 2007?
Offer a terse response. 1.49. What is the ratio of the Aid flow (current US$) of Namibia in 2004 to that in 2005?
Your answer should be compact. 3.08. What is the ratio of the Aid flow (current US$) of Tunisia in 2004 to that in 2005?
Provide a succinct answer. 1.17. What is the ratio of the Aid flow (current US$) in Venezuela in 2004 to that in 2005?
Your answer should be compact. 1.06. What is the ratio of the Aid flow (current US$) in Namibia in 2004 to that in 2006?
Ensure brevity in your answer.  1.19. What is the ratio of the Aid flow (current US$) in Tunisia in 2004 to that in 2006?
Your answer should be compact. 3.22. What is the ratio of the Aid flow (current US$) of Venezuela in 2004 to that in 2006?
Offer a very short reply. 1.65. What is the ratio of the Aid flow (current US$) in Namibia in 2004 to that in 2007?
Ensure brevity in your answer.  0.21. What is the ratio of the Aid flow (current US$) in Tunisia in 2004 to that in 2007?
Offer a terse response. 2.91. What is the ratio of the Aid flow (current US$) in Venezuela in 2004 to that in 2007?
Give a very brief answer. 1.93. What is the ratio of the Aid flow (current US$) of Namibia in 2005 to that in 2006?
Your answer should be very brief. 0.39. What is the ratio of the Aid flow (current US$) in Tunisia in 2005 to that in 2006?
Give a very brief answer. 2.75. What is the ratio of the Aid flow (current US$) in Venezuela in 2005 to that in 2006?
Your response must be concise. 1.56. What is the ratio of the Aid flow (current US$) in Namibia in 2005 to that in 2007?
Offer a terse response. 0.07. What is the ratio of the Aid flow (current US$) in Tunisia in 2005 to that in 2007?
Give a very brief answer. 2.49. What is the ratio of the Aid flow (current US$) in Venezuela in 2005 to that in 2007?
Provide a succinct answer. 1.82. What is the ratio of the Aid flow (current US$) of Namibia in 2006 to that in 2007?
Provide a short and direct response. 0.18. What is the ratio of the Aid flow (current US$) of Tunisia in 2006 to that in 2007?
Give a very brief answer. 0.9. What is the ratio of the Aid flow (current US$) in Venezuela in 2006 to that in 2007?
Offer a very short reply. 1.17. What is the difference between the highest and the second highest Aid flow (current US$) of Tunisia?
Offer a very short reply. 2.93e+06. What is the difference between the highest and the lowest Aid flow (current US$) of Namibia?
Your response must be concise. 5.35e+06. What is the difference between the highest and the lowest Aid flow (current US$) in Syrian Arab Republic?
Give a very brief answer. 6.44e+07. What is the difference between the highest and the lowest Aid flow (current US$) of Tunisia?
Your answer should be compact. 6.99e+07. What is the difference between the highest and the lowest Aid flow (current US$) of Venezuela?
Give a very brief answer. 2.20e+06. 